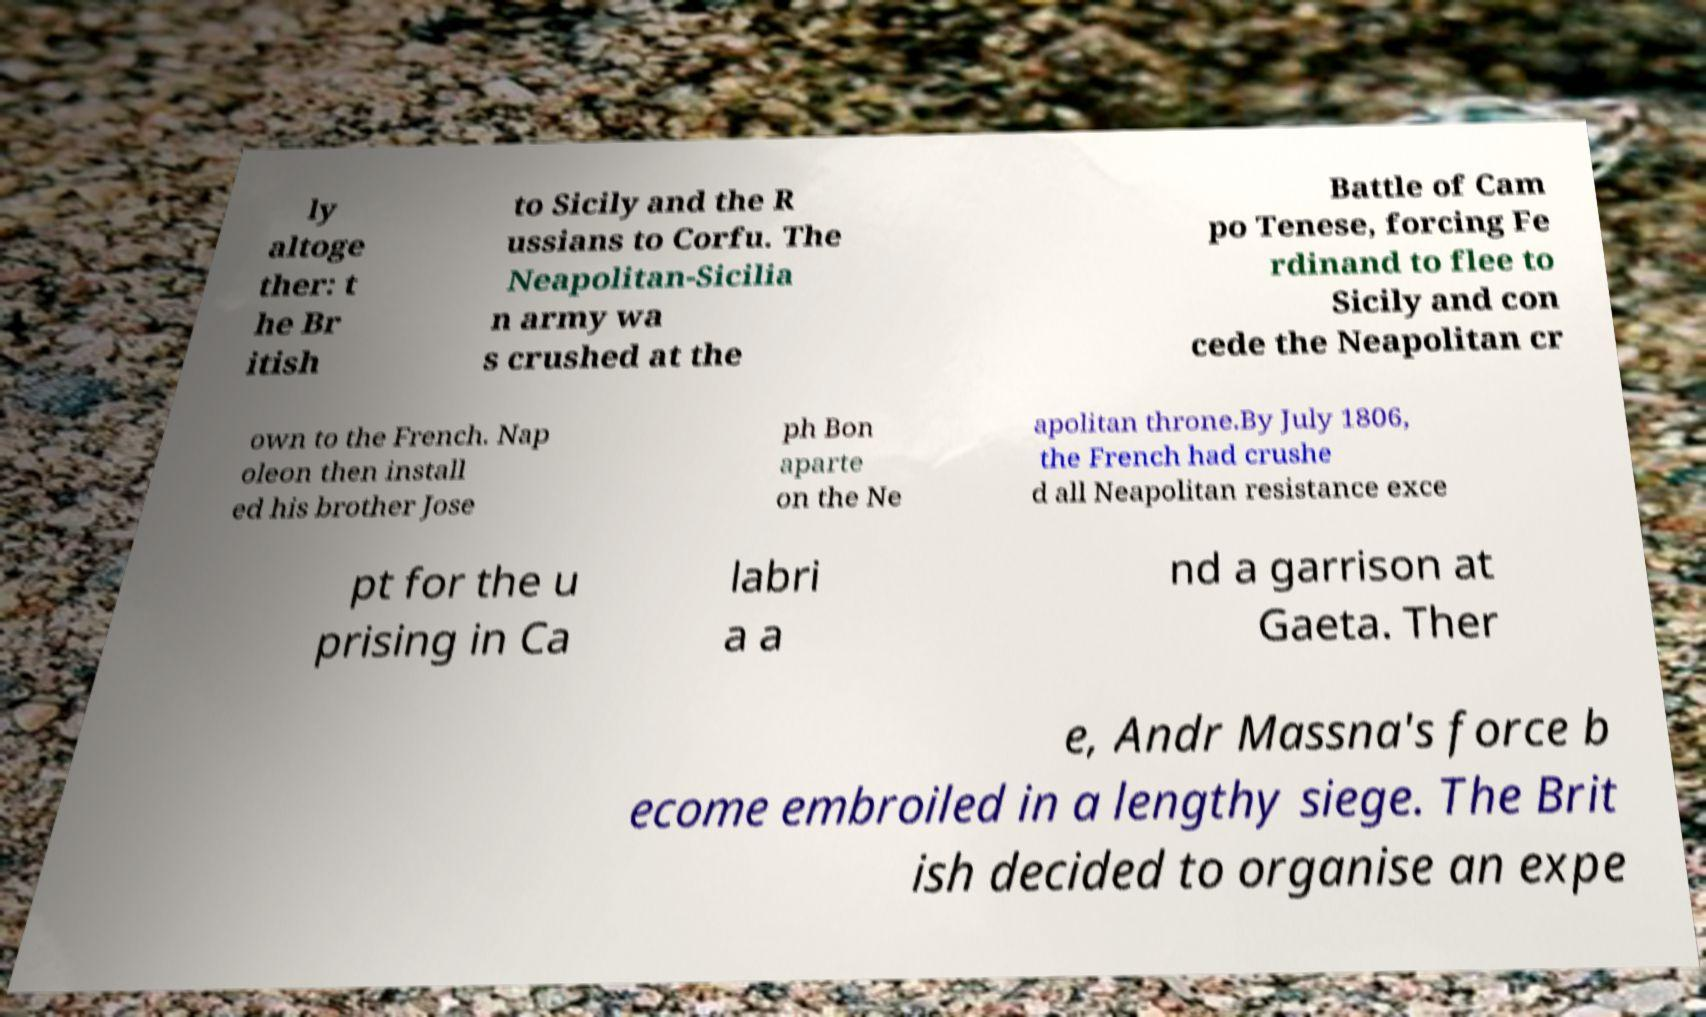Please identify and transcribe the text found in this image. ly altoge ther: t he Br itish to Sicily and the R ussians to Corfu. The Neapolitan-Sicilia n army wa s crushed at the Battle of Cam po Tenese, forcing Fe rdinand to flee to Sicily and con cede the Neapolitan cr own to the French. Nap oleon then install ed his brother Jose ph Bon aparte on the Ne apolitan throne.By July 1806, the French had crushe d all Neapolitan resistance exce pt for the u prising in Ca labri a a nd a garrison at Gaeta. Ther e, Andr Massna's force b ecome embroiled in a lengthy siege. The Brit ish decided to organise an expe 